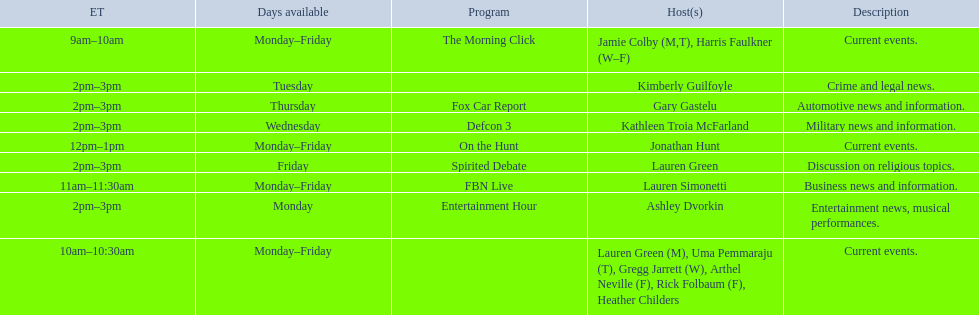Who are all of the hosts? Jamie Colby (M,T), Harris Faulkner (W–F), Lauren Green (M), Uma Pemmaraju (T), Gregg Jarrett (W), Arthel Neville (F), Rick Folbaum (F), Heather Childers, Lauren Simonetti, Jonathan Hunt, Ashley Dvorkin, Kimberly Guilfoyle, Kathleen Troia McFarland, Gary Gastelu, Lauren Green. Which hosts have shows on fridays? Jamie Colby (M,T), Harris Faulkner (W–F), Lauren Green (M), Uma Pemmaraju (T), Gregg Jarrett (W), Arthel Neville (F), Rick Folbaum (F), Heather Childers, Lauren Simonetti, Jonathan Hunt, Lauren Green. Of those, which host's show airs at 2pm? Lauren Green. 